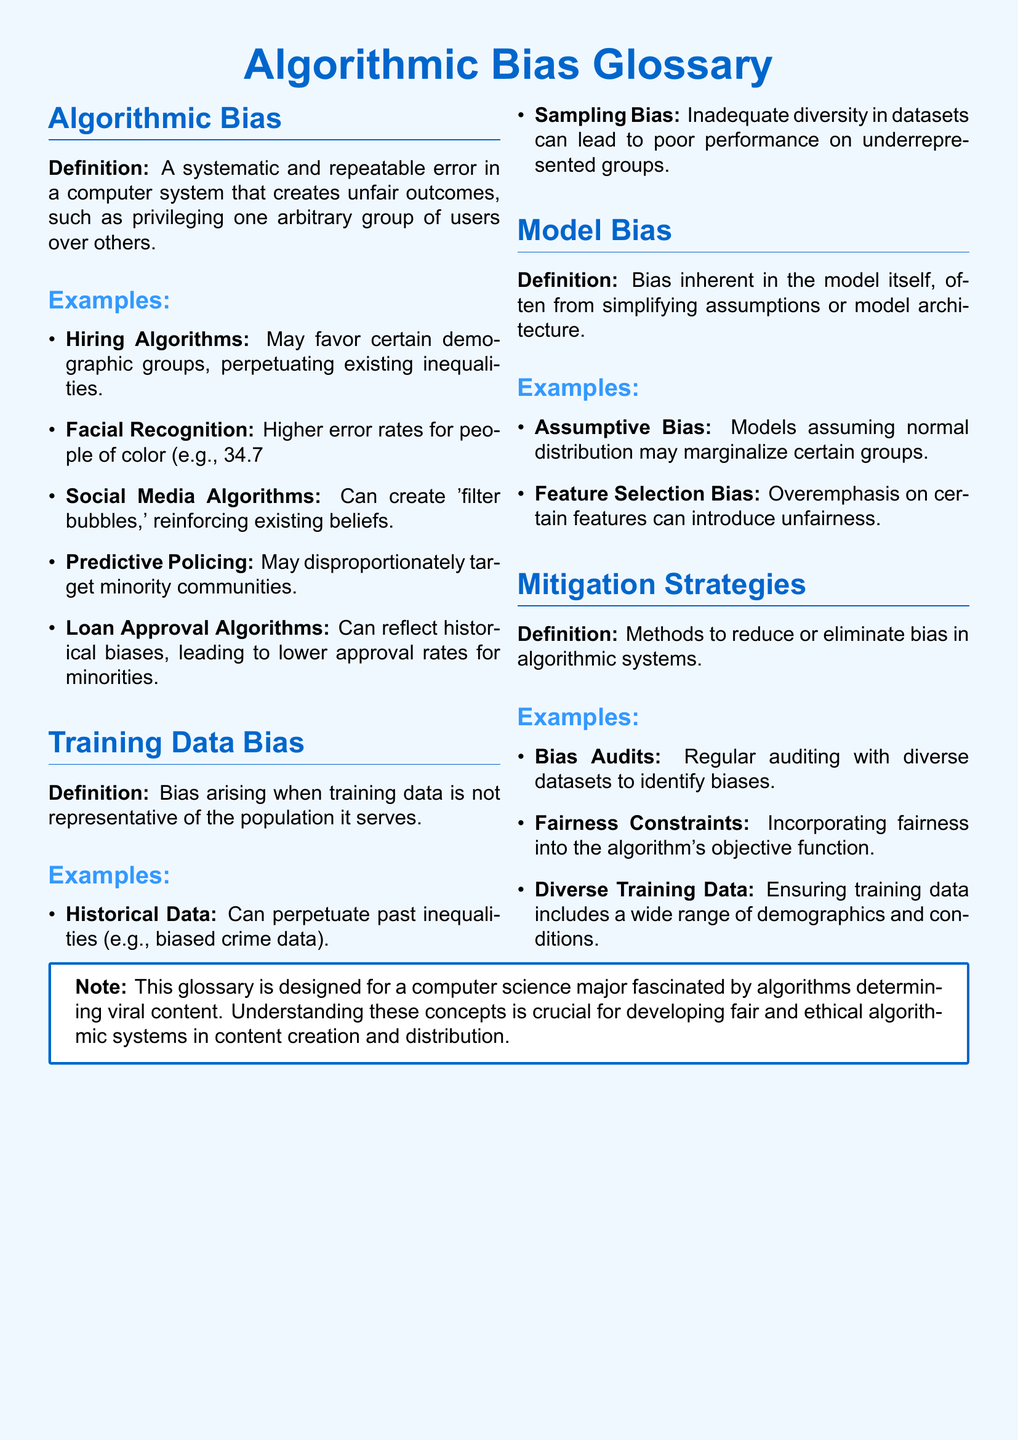What is algorithmic bias? Algorithmic bias is defined in the document as a systematic and repeatable error in a computer system that creates unfair outcomes.
Answer: A systematic and repeatable error What is an example of bias in hiring algorithms? The document provides hiring algorithms as an example, explaining they may favor certain demographic groups.
Answer: Favor certain demographic groups What error rate does facial recognition have for darker-skinned women? The document states a specific error rate for darker-skinned women in facial recognition.
Answer: 34.7% What type of bias arises from unrepresentative training data? The document defines a specific type of bias related to training data that is not representative.
Answer: Training data bias What is one strategy to mitigate algorithmic bias? The document lists several strategies and asks for any strategy to reduce bias in algorithms.
Answer: Bias audits What type of bias may occur due to the model's architecture? The document identifies a bias that is inherent in the model itself.
Answer: Model bias What is the role of fairness constraints in algorithms? The document describes fairness constraints as a method incorporated into the algorithm's objective function.
Answer: To incorporate fairness What does 'sampling bias' refer to? The document provides a definition for sampling bias in the context of training data.
Answer: Inadequate diversity in datasets What demographic aspects should diverse training data include? The document emphasizes that diverse training data should cover a wide range of demographics and conditions.
Answer: A wide range of demographics and conditions 